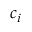<formula> <loc_0><loc_0><loc_500><loc_500>c _ { i }</formula> 